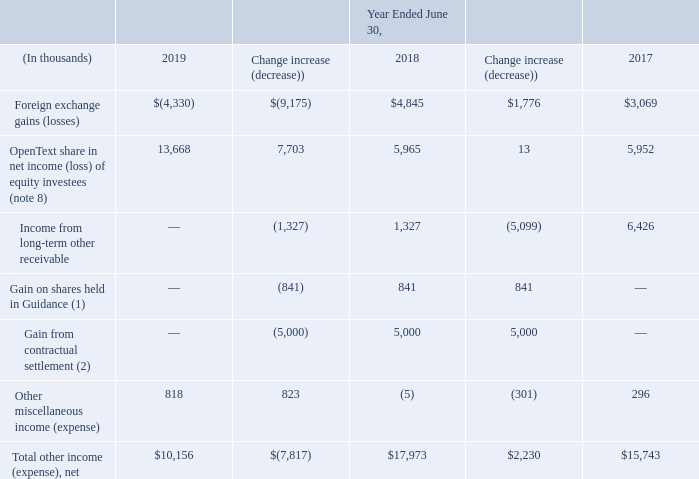Other Income (Expense), Net
Other income (expense), net relates to certain non-operational charges primarily consisting of income or losses in our share of marketable equity securities accounted for under the equity method and of transactional foreign exchange gains (losses). The income (expense) from foreign exchange is dependent upon the change in foreign currency exchange rates vis-àvis the functional currency of the legal entity.
(1) Represents the release to income from other comprehensive income relating to the mark to market on shares we held in Guidance prior to our acquisition in the first quarter of Fiscal 2018.
(2) Represents a gain recognized in connection with the settlement of a certain breach of contractual arrangement in the second quarter of Fiscal 2018.
What is the income (expense) from foreign exchange is dependent on? The change in foreign currency exchange rates vis-àvis the functional currency of the legal entity. What years are included in the table? 2019, 2018, 2017. What are the units used in the table? Thousands. What is the average annual Total other income (expense), net?
Answer scale should be: thousand. (10,156+17,973+15,743)/3
Answer: 14624. What is the percentage change of Total other income (expense), net for fiscal year 2018 to 2019?
Answer scale should be: percent. -7,817/17,973
Answer: -43.49. What is the change of Total other income (expense), net from fiscal year 2017 to 2019?
Answer scale should be: thousand. -7,817+2,230
Answer: -5587. 